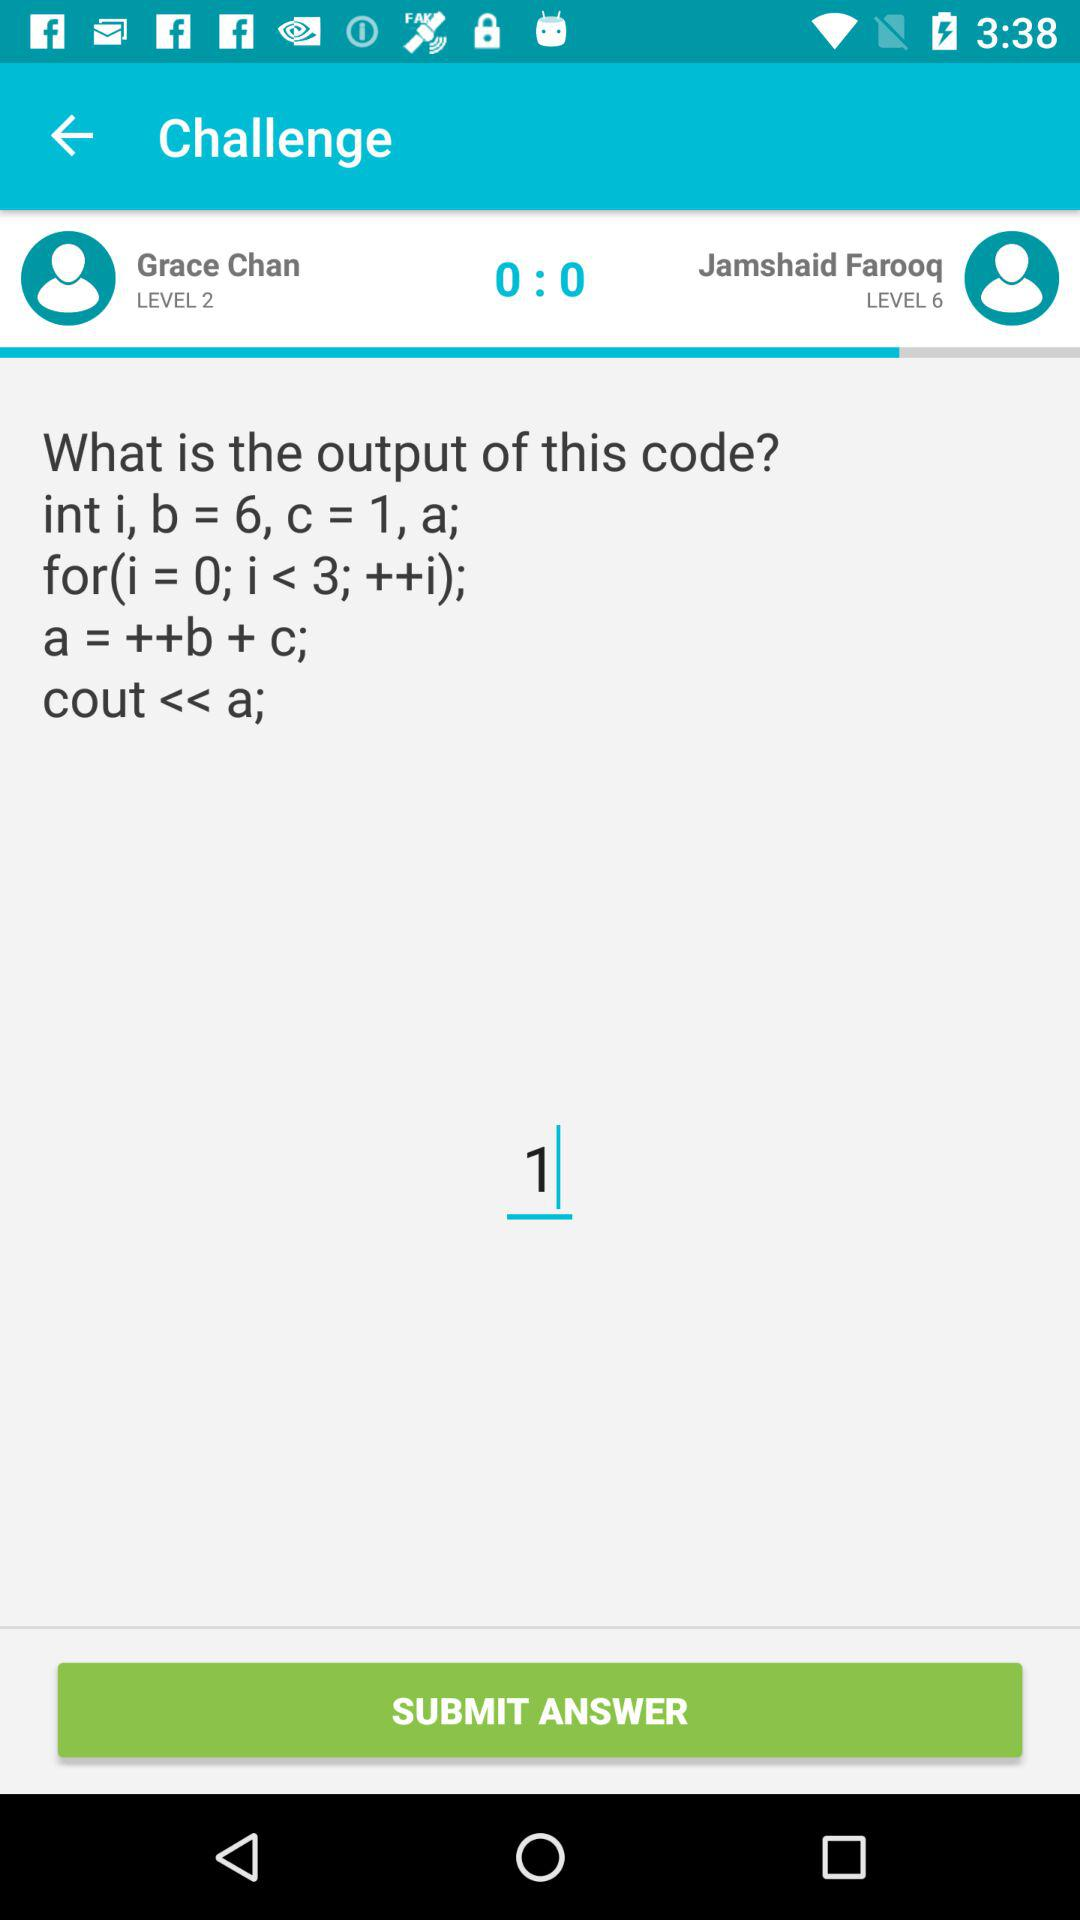Who is on level 6? The person who is on level 6 is Jamshaid Farooq. 